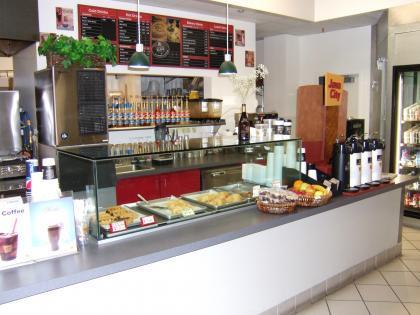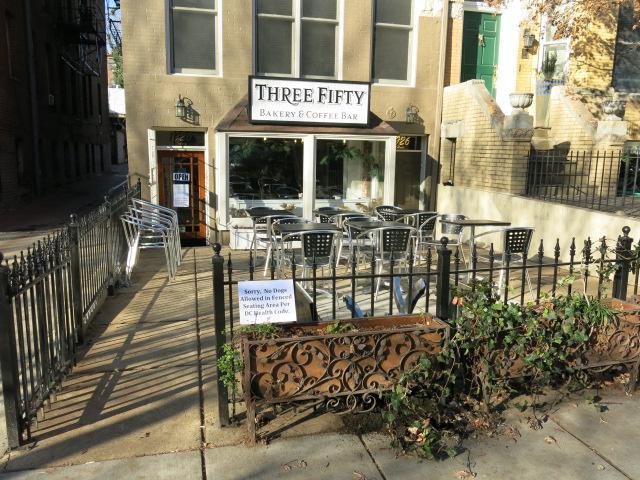The first image is the image on the left, the second image is the image on the right. For the images shown, is this caption "At least one woman with her hair up is working behind the counter of one bakery." true? Answer yes or no. No. The first image is the image on the left, the second image is the image on the right. Analyze the images presented: Is the assertion "The only humans visible appear to be workers." valid? Answer yes or no. No. 